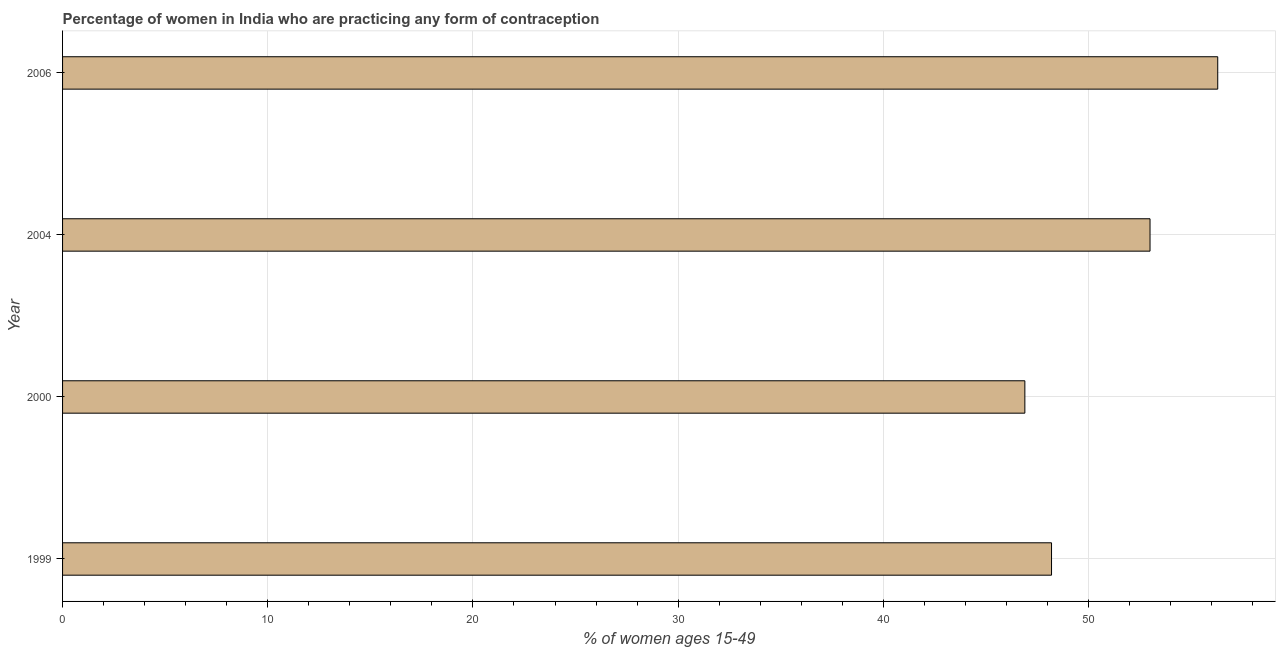Does the graph contain grids?
Offer a terse response. Yes. What is the title of the graph?
Ensure brevity in your answer.  Percentage of women in India who are practicing any form of contraception. What is the label or title of the X-axis?
Make the answer very short. % of women ages 15-49. What is the label or title of the Y-axis?
Your answer should be compact. Year. What is the contraceptive prevalence in 2006?
Provide a short and direct response. 56.3. Across all years, what is the maximum contraceptive prevalence?
Your answer should be compact. 56.3. Across all years, what is the minimum contraceptive prevalence?
Your response must be concise. 46.9. In which year was the contraceptive prevalence maximum?
Make the answer very short. 2006. What is the sum of the contraceptive prevalence?
Your answer should be very brief. 204.4. What is the difference between the contraceptive prevalence in 1999 and 2000?
Ensure brevity in your answer.  1.3. What is the average contraceptive prevalence per year?
Make the answer very short. 51.1. What is the median contraceptive prevalence?
Keep it short and to the point. 50.6. In how many years, is the contraceptive prevalence greater than 26 %?
Offer a terse response. 4. Do a majority of the years between 1999 and 2006 (inclusive) have contraceptive prevalence greater than 18 %?
Offer a very short reply. Yes. What is the ratio of the contraceptive prevalence in 1999 to that in 2006?
Your answer should be compact. 0.86. Is the contraceptive prevalence in 2000 less than that in 2006?
Offer a very short reply. Yes. Is the sum of the contraceptive prevalence in 1999 and 2004 greater than the maximum contraceptive prevalence across all years?
Make the answer very short. Yes. In how many years, is the contraceptive prevalence greater than the average contraceptive prevalence taken over all years?
Your response must be concise. 2. Are all the bars in the graph horizontal?
Provide a short and direct response. Yes. How many years are there in the graph?
Give a very brief answer. 4. What is the % of women ages 15-49 of 1999?
Your answer should be very brief. 48.2. What is the % of women ages 15-49 of 2000?
Provide a succinct answer. 46.9. What is the % of women ages 15-49 of 2004?
Offer a very short reply. 53. What is the % of women ages 15-49 of 2006?
Give a very brief answer. 56.3. What is the difference between the % of women ages 15-49 in 1999 and 2000?
Make the answer very short. 1.3. What is the difference between the % of women ages 15-49 in 1999 and 2006?
Give a very brief answer. -8.1. What is the difference between the % of women ages 15-49 in 2000 and 2004?
Give a very brief answer. -6.1. What is the difference between the % of women ages 15-49 in 2000 and 2006?
Offer a terse response. -9.4. What is the difference between the % of women ages 15-49 in 2004 and 2006?
Your answer should be compact. -3.3. What is the ratio of the % of women ages 15-49 in 1999 to that in 2000?
Your answer should be compact. 1.03. What is the ratio of the % of women ages 15-49 in 1999 to that in 2004?
Your answer should be compact. 0.91. What is the ratio of the % of women ages 15-49 in 1999 to that in 2006?
Offer a terse response. 0.86. What is the ratio of the % of women ages 15-49 in 2000 to that in 2004?
Give a very brief answer. 0.89. What is the ratio of the % of women ages 15-49 in 2000 to that in 2006?
Your answer should be very brief. 0.83. What is the ratio of the % of women ages 15-49 in 2004 to that in 2006?
Keep it short and to the point. 0.94. 